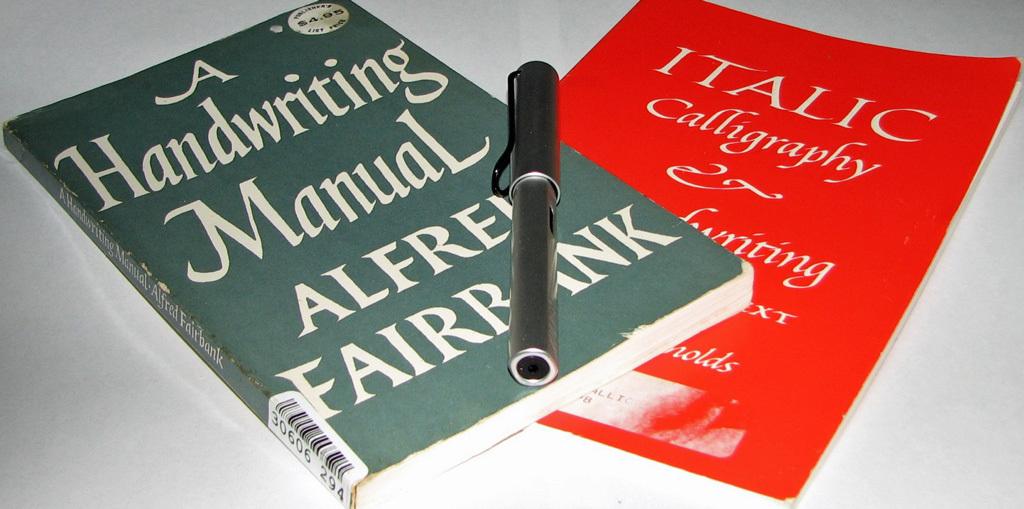What are these books about?
Give a very brief answer. Handwriting. What is the title of the left book?
Ensure brevity in your answer.  A handwriting manual. 